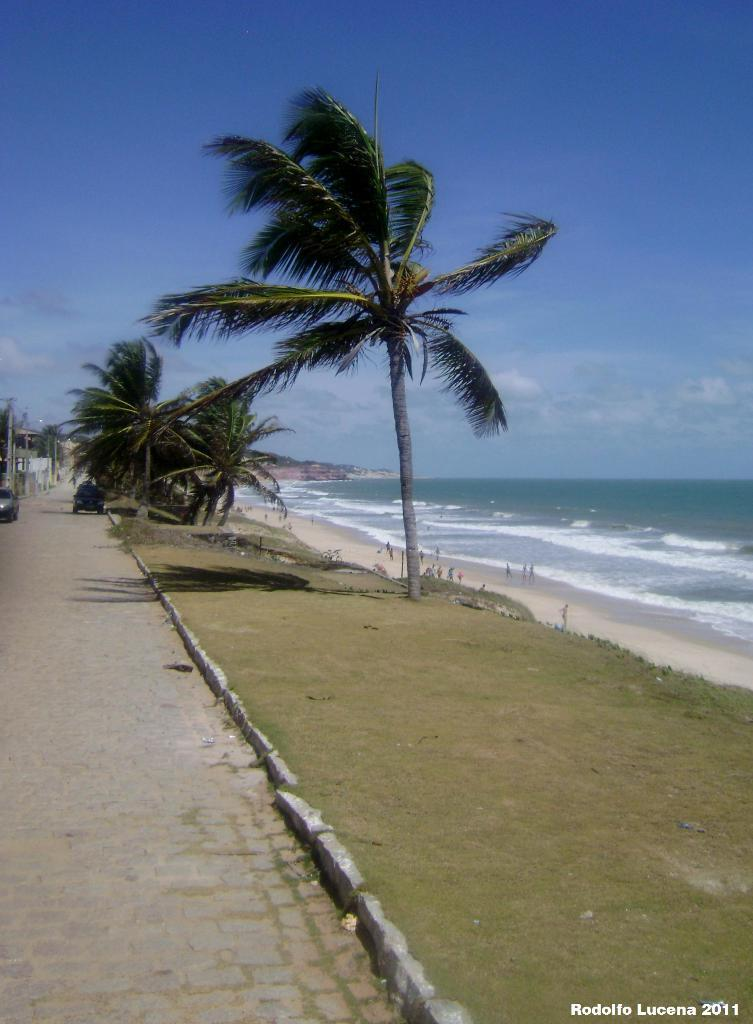What is the main feature of the image? There is a road in the image. What can be seen on the road? There are two vehicles on the road. What type of natural environment is visible in the image? There is grass, trees, and water visible in the image. Where are the people located in the image? The people are on the beach in the image. What is visible in the background of the image? The sky is visible in the background of the image. Can you see a stamp being used by the people on the beach in the image? There is no stamp visible in the image, nor is there any indication that the people on the beach are using a stamp. 